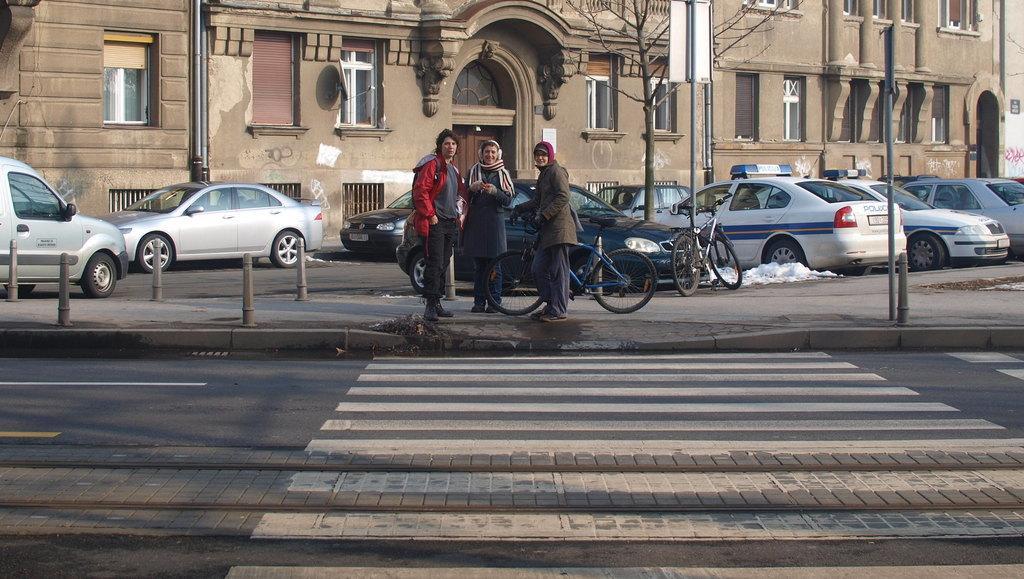Describe this image in one or two sentences. In this image a person wearing a red jacket is standing on the pavement beside to a person wearing a scarf. Beside there is a person leaning on the bicycle which is on the pavement having few bicycle and few cars on it. There is a pole attached with the board. Beside there is a tree. Beside the bicycle there is some snow. There are few poles on the pavement. Bottom of image there is road. Top of image there is a building having few doors and windows. 